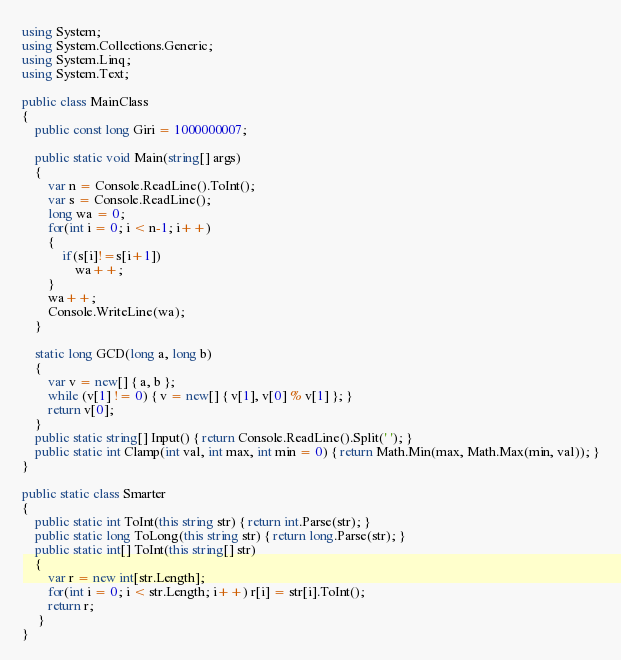Convert code to text. <code><loc_0><loc_0><loc_500><loc_500><_C#_>using System;
using System.Collections.Generic;
using System.Linq;
using System.Text;

public class MainClass
{
	public const long Giri = 1000000007;

	public static void Main(string[] args)
	{
		var n = Console.ReadLine().ToInt();
		var s = Console.ReadLine();
		long wa = 0;
		for(int i = 0; i < n-1; i++)
		{
			if(s[i]!=s[i+1])
				wa++;
		}
		wa++;
		Console.WriteLine(wa);
	}
	
	static long GCD(long a, long b)
	{
		var v = new[] { a, b };
		while (v[1] != 0) { v = new[] { v[1], v[0] % v[1] }; }
		return v[0];
	}
	public static string[] Input() { return Console.ReadLine().Split(' '); }
	public static int Clamp(int val, int max, int min = 0) { return Math.Min(max, Math.Max(min, val)); }
}

public static class Smarter
{
	public static int ToInt(this string str) { return int.Parse(str); }
	public static long ToLong(this string str) { return long.Parse(str); }
	public static int[] ToInt(this string[] str)
	{
		var r = new int[str.Length];
		for(int i = 0; i < str.Length; i++) r[i] = str[i].ToInt();
		return r;
	 }
}</code> 